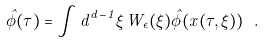Convert formula to latex. <formula><loc_0><loc_0><loc_500><loc_500>\hat { \phi } ( \tau ) = \int d ^ { d - 1 } \xi \, W _ { \epsilon } ( \xi ) \hat { \phi } ( x ( \tau , \xi ) ) \ .</formula> 